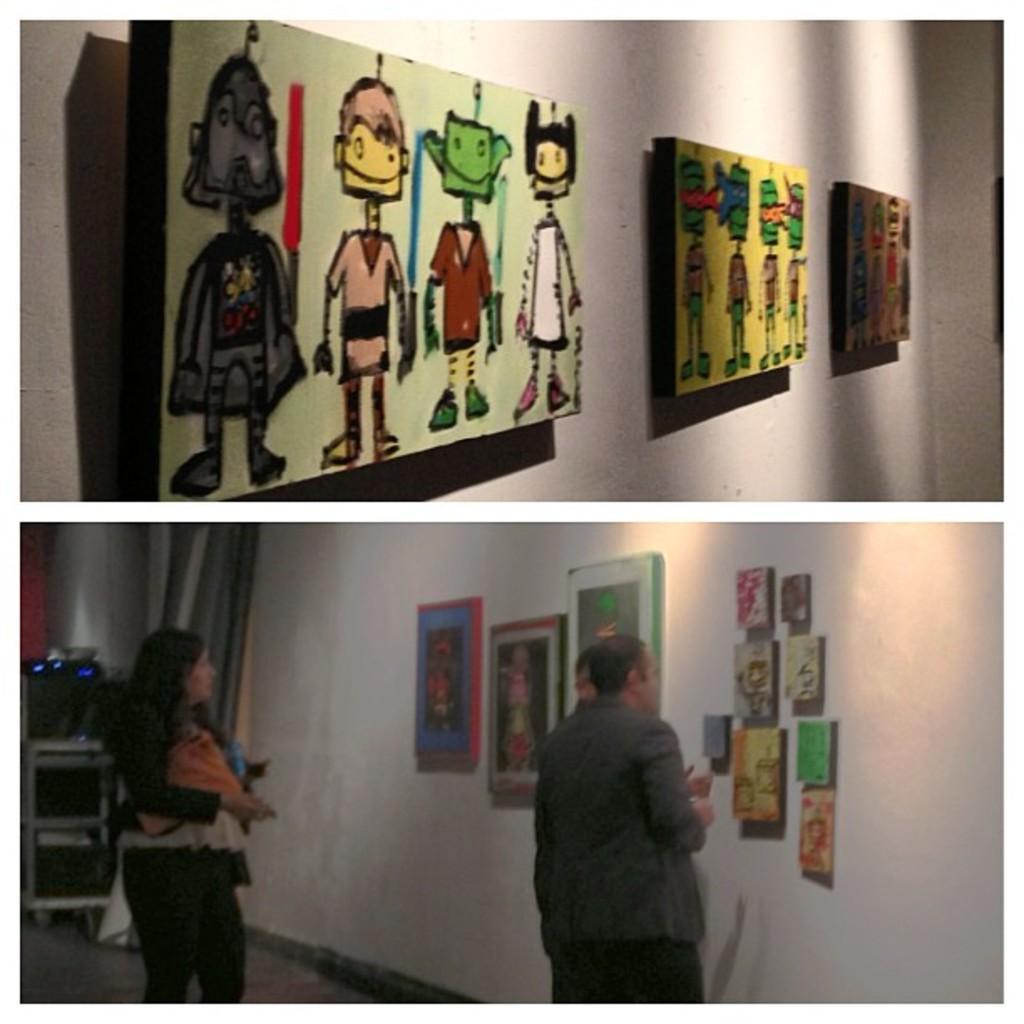In one or two sentences, can you explain what this image depicts? This is the collage pictures of wall, paintings, persons. 